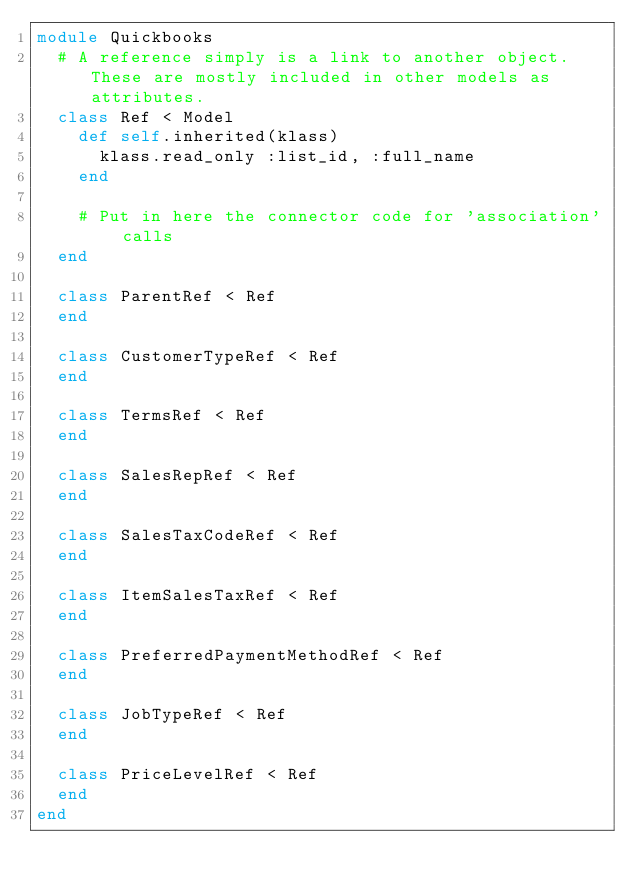Convert code to text. <code><loc_0><loc_0><loc_500><loc_500><_Ruby_>module Quickbooks
  # A reference simply is a link to another object. These are mostly included in other models as attributes.
  class Ref < Model
    def self.inherited(klass)
      klass.read_only :list_id, :full_name
    end

    # Put in here the connector code for 'association' calls
  end
  
  class ParentRef < Ref
  end
  
  class CustomerTypeRef < Ref
  end
  
  class TermsRef < Ref
  end
  
  class SalesRepRef < Ref
  end
  
  class SalesTaxCodeRef < Ref
  end
  
  class ItemSalesTaxRef < Ref
  end
  
  class PreferredPaymentMethodRef < Ref
  end
  
  class JobTypeRef < Ref
  end
  
  class PriceLevelRef < Ref
  end
end
</code> 